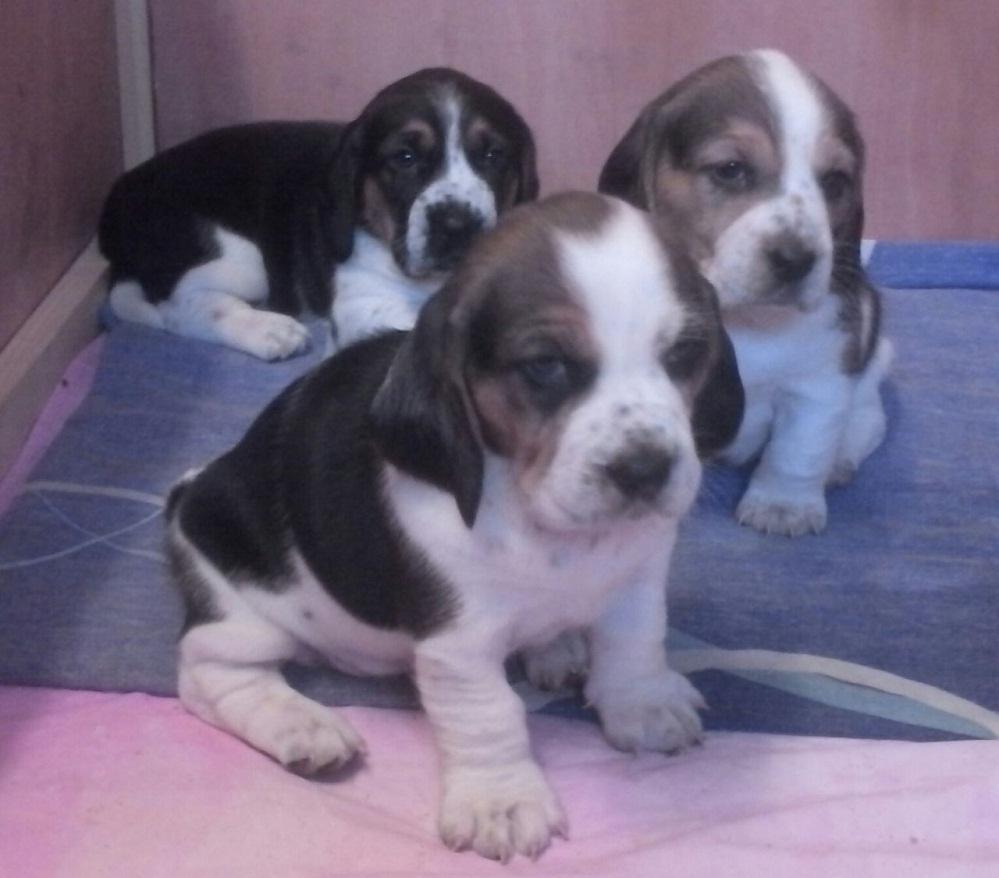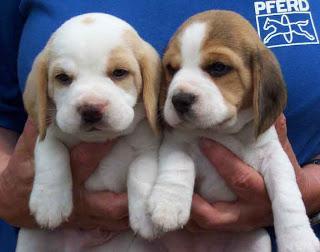The first image is the image on the left, the second image is the image on the right. For the images displayed, is the sentence "There are no less than three beagle puppies" factually correct? Answer yes or no. Yes. The first image is the image on the left, the second image is the image on the right. Examine the images to the left and right. Is the description "The left image contains at least two dogs." accurate? Answer yes or no. Yes. 